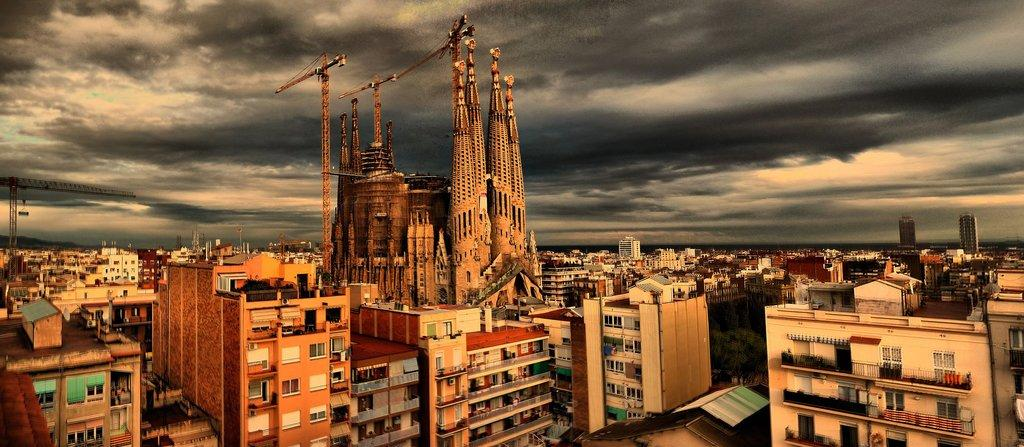What structures are located in the center of the image? There are buildings, towers, a shed, trees, grills, windows, and a wall in the center of the image. What can be seen on top of the buildings in the image? There are towers on top of the buildings in the image. What type of vegetation is present in the center of the image? There are trees in the center of the image. What might be used for cooking in the image? Grills are present in the center of the image for cooking. What architectural feature is common among the buildings in the image? Windows are present in the buildings in the image. What is visible at the top of the image? Clouds are present in the sky at the top of the image. What type of bubble is floating above the trees in the image? There is no bubble present in the image; it only features buildings, towers, a shed, trees, grills, windows, a wall, and clouds in the sky. What educational institution can be seen in the image? There is no educational institution present in the image. What type of mitten is being used to hold the grills in the image? There are no mittens present in the image; the grills are being held by people or are placed on a surface. 